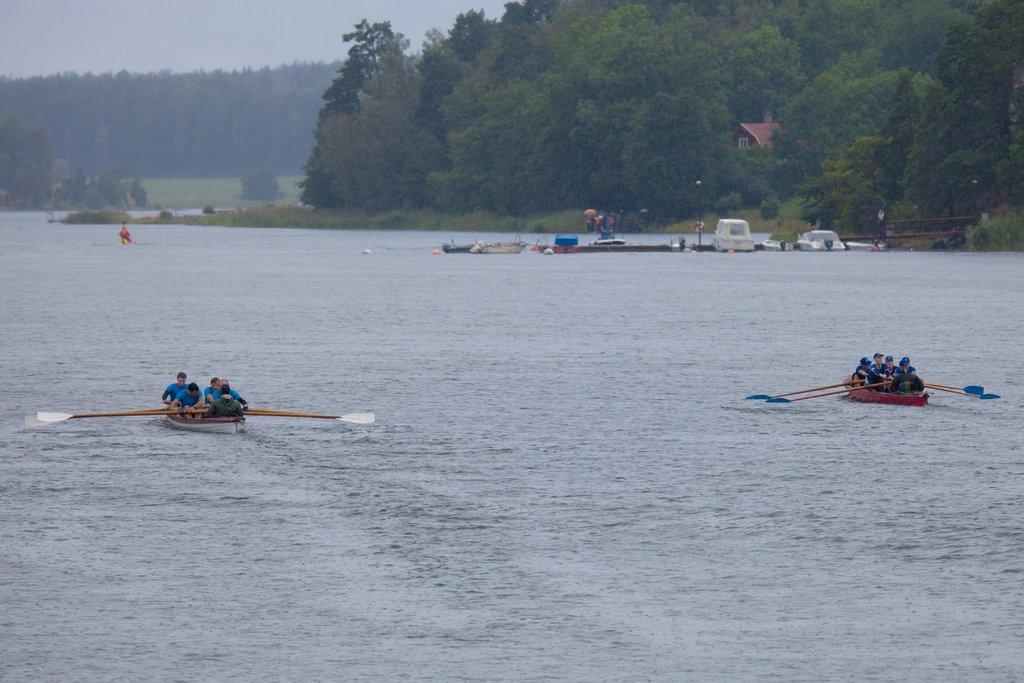What are the people in the image doing? The people in the image are sitting in boats on the water. What are the people using to move the boats? The people are holding rows in their hands. What can be seen in the background of the image? There is a building visible in the image, as well as trees. What type of structure is present in the image? There is a walkway bridge in the image. What is visible above the water and structures in the image? The sky is visible in the image. What type of powder can be seen covering the wilderness in the image? There is no wilderness or powder present in the image. The image features people in boats on the water, with a building, trees, a walkway bridge, and the sky visible in the background. 